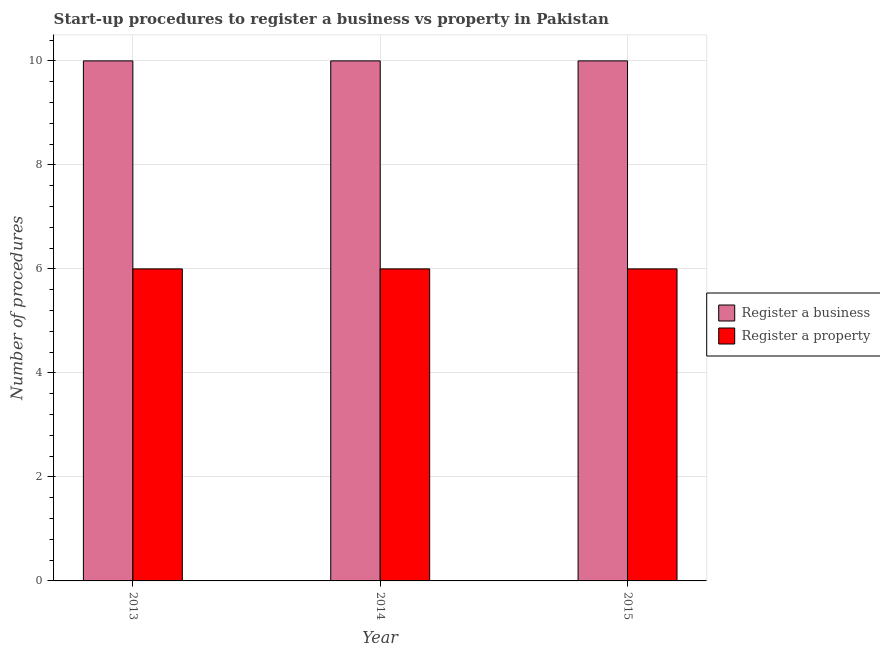How many different coloured bars are there?
Your response must be concise. 2. Are the number of bars on each tick of the X-axis equal?
Offer a terse response. Yes. What is the label of the 1st group of bars from the left?
Give a very brief answer. 2013. In how many cases, is the number of bars for a given year not equal to the number of legend labels?
Provide a succinct answer. 0. What is the number of procedures to register a property in 2014?
Your answer should be very brief. 6. Across all years, what is the maximum number of procedures to register a business?
Make the answer very short. 10. In which year was the number of procedures to register a business minimum?
Provide a succinct answer. 2013. What is the total number of procedures to register a property in the graph?
Your answer should be very brief. 18. What is the difference between the number of procedures to register a property in 2013 and that in 2014?
Provide a short and direct response. 0. What is the average number of procedures to register a property per year?
Offer a terse response. 6. In the year 2014, what is the difference between the number of procedures to register a business and number of procedures to register a property?
Provide a succinct answer. 0. In how many years, is the number of procedures to register a property greater than 6.8?
Your answer should be compact. 0. Is the sum of the number of procedures to register a property in 2013 and 2014 greater than the maximum number of procedures to register a business across all years?
Your response must be concise. Yes. What does the 1st bar from the left in 2015 represents?
Your response must be concise. Register a business. What does the 2nd bar from the right in 2014 represents?
Provide a short and direct response. Register a business. How many bars are there?
Provide a succinct answer. 6. Are all the bars in the graph horizontal?
Make the answer very short. No. What is the difference between two consecutive major ticks on the Y-axis?
Ensure brevity in your answer.  2. Does the graph contain grids?
Ensure brevity in your answer.  Yes. Where does the legend appear in the graph?
Your response must be concise. Center right. How many legend labels are there?
Your response must be concise. 2. What is the title of the graph?
Your response must be concise. Start-up procedures to register a business vs property in Pakistan. What is the label or title of the X-axis?
Provide a short and direct response. Year. What is the label or title of the Y-axis?
Provide a short and direct response. Number of procedures. What is the Number of procedures of Register a property in 2013?
Your response must be concise. 6. What is the Number of procedures of Register a property in 2014?
Provide a succinct answer. 6. Across all years, what is the maximum Number of procedures of Register a property?
Give a very brief answer. 6. What is the total Number of procedures of Register a business in the graph?
Your response must be concise. 30. What is the difference between the Number of procedures in Register a business in 2013 and that in 2014?
Make the answer very short. 0. What is the difference between the Number of procedures of Register a property in 2013 and that in 2014?
Ensure brevity in your answer.  0. What is the difference between the Number of procedures in Register a business in 2013 and the Number of procedures in Register a property in 2014?
Ensure brevity in your answer.  4. What is the difference between the Number of procedures in Register a business in 2013 and the Number of procedures in Register a property in 2015?
Offer a terse response. 4. What is the difference between the Number of procedures in Register a business in 2014 and the Number of procedures in Register a property in 2015?
Ensure brevity in your answer.  4. What is the average Number of procedures of Register a business per year?
Provide a short and direct response. 10. What is the ratio of the Number of procedures in Register a business in 2013 to that in 2014?
Offer a terse response. 1. What is the ratio of the Number of procedures in Register a property in 2013 to that in 2014?
Give a very brief answer. 1. What is the ratio of the Number of procedures in Register a business in 2013 to that in 2015?
Provide a succinct answer. 1. What is the ratio of the Number of procedures in Register a business in 2014 to that in 2015?
Offer a very short reply. 1. What is the ratio of the Number of procedures of Register a property in 2014 to that in 2015?
Your answer should be compact. 1. What is the difference between the highest and the second highest Number of procedures in Register a business?
Provide a short and direct response. 0. 